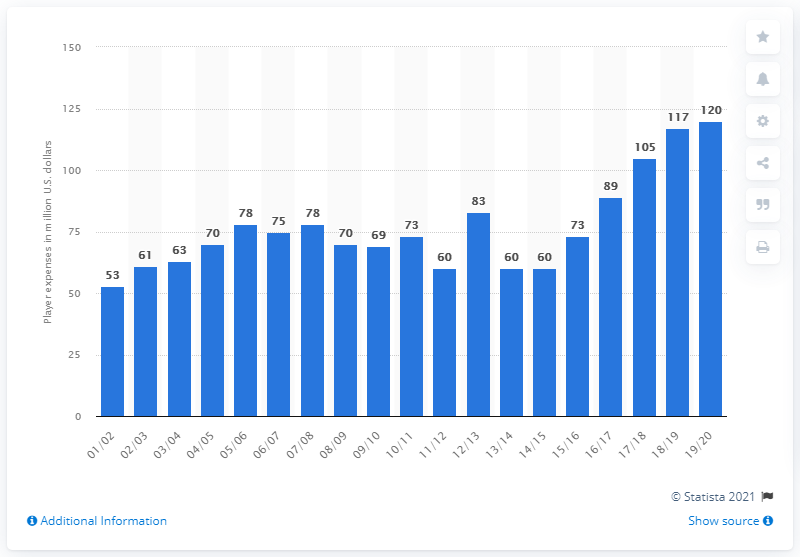Highlight a few significant elements in this photo. The player salaries of the Philadelphia 76ers in the 2019/20 season were $120 million. 